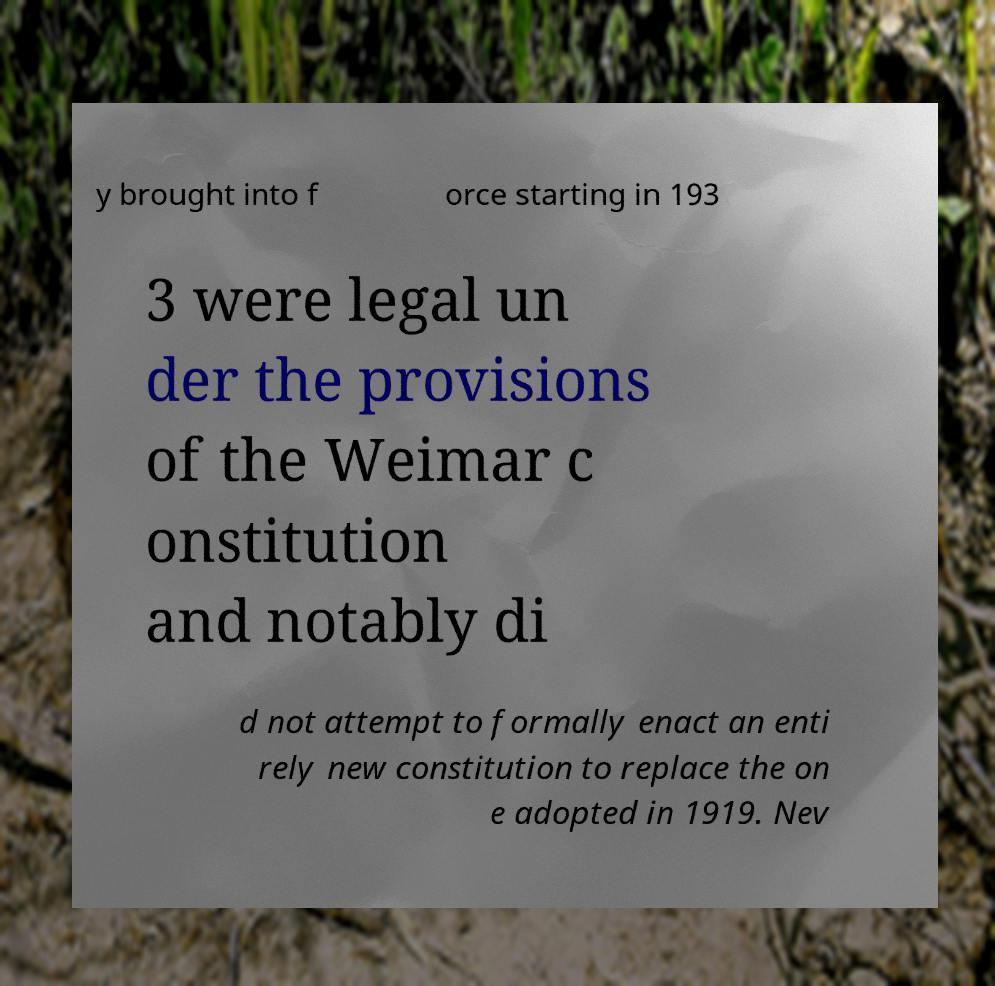Could you assist in decoding the text presented in this image and type it out clearly? y brought into f orce starting in 193 3 were legal un der the provisions of the Weimar c onstitution and notably di d not attempt to formally enact an enti rely new constitution to replace the on e adopted in 1919. Nev 